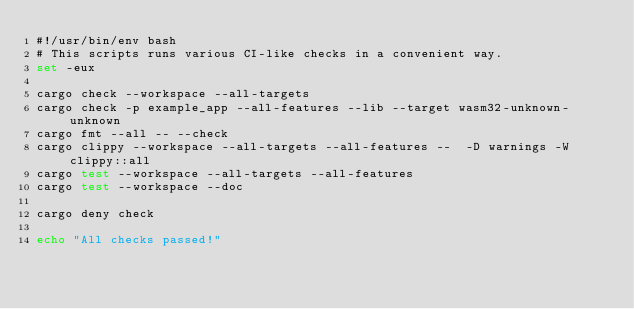<code> <loc_0><loc_0><loc_500><loc_500><_Bash_>#!/usr/bin/env bash
# This scripts runs various CI-like checks in a convenient way.
set -eux

cargo check --workspace --all-targets
cargo check -p example_app --all-features --lib --target wasm32-unknown-unknown
cargo fmt --all -- --check
cargo clippy --workspace --all-targets --all-features --  -D warnings -W clippy::all
cargo test --workspace --all-targets --all-features
cargo test --workspace --doc

cargo deny check

echo "All checks passed!"
</code> 